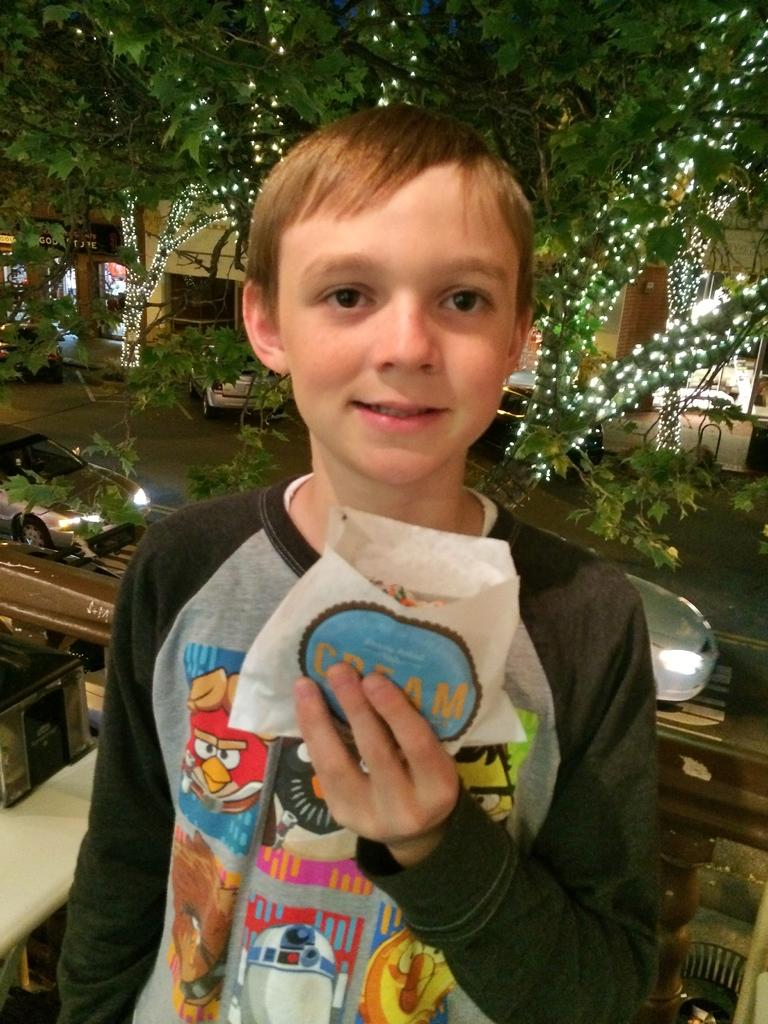What is the main subject of the image? There is a boy standing in the image. What is the boy holding in the image? The boy is holding an object. What can be seen on the road in the image? There are vehicles on the road in the image. What is visible in the background of the image? There are buildings, lights, and trees in the background of the image. What type of fowl can be seen flying over the boy in the image? There is no fowl visible in the image; it only shows a boy standing and holding an object, vehicles on the road, and the background with buildings, lights, and trees. 